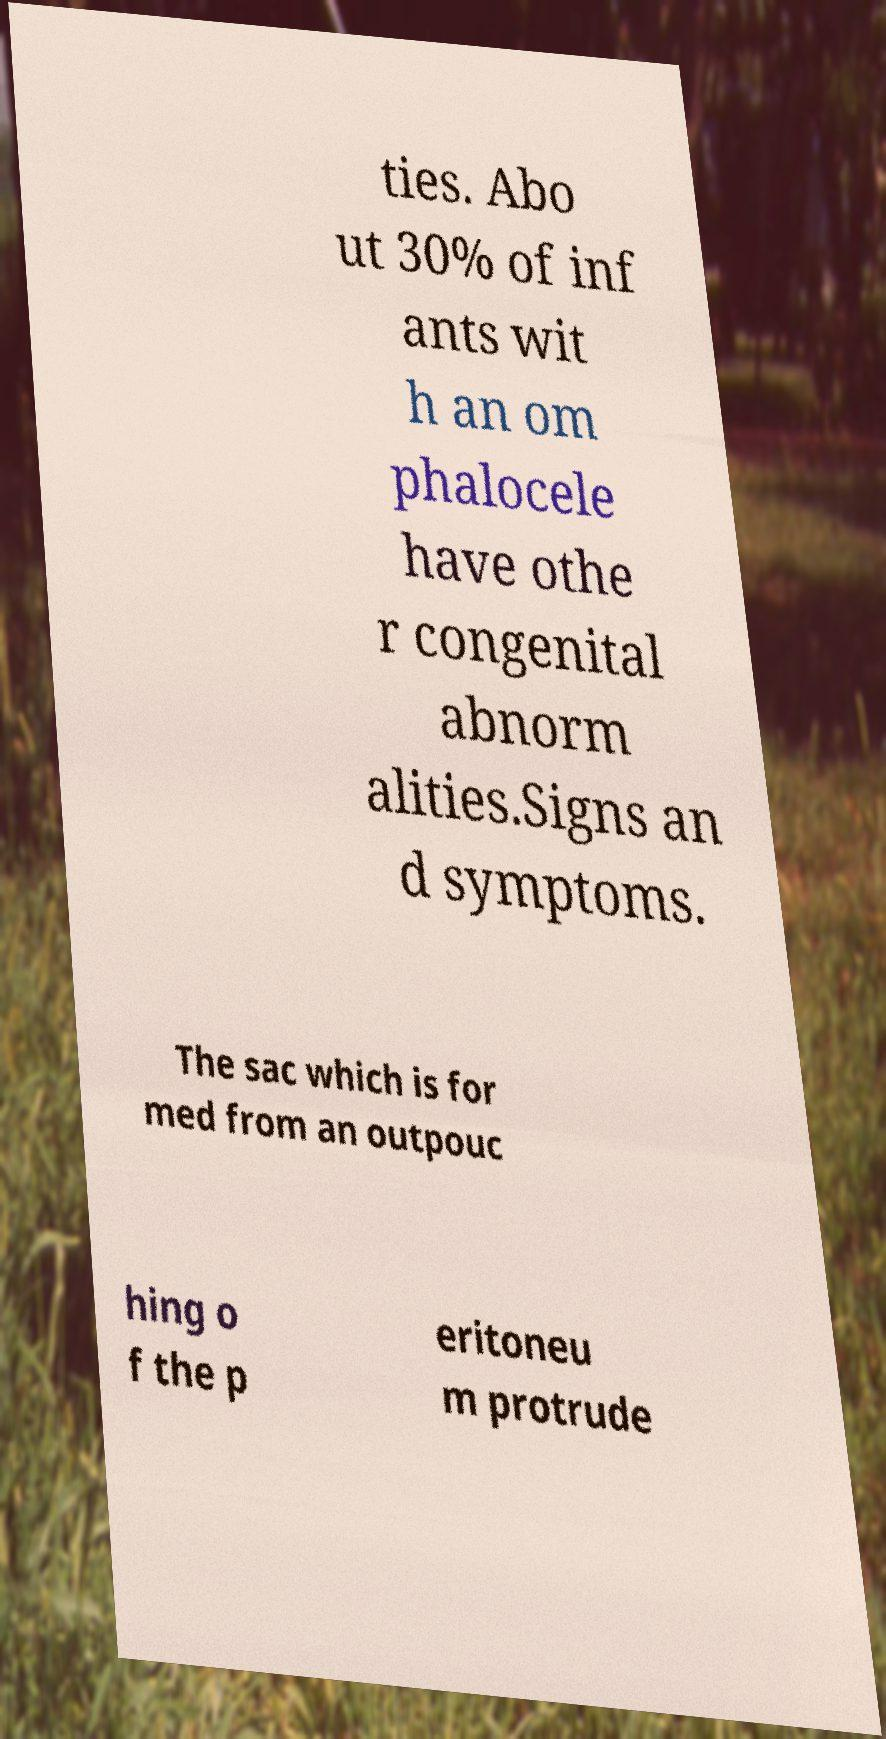There's text embedded in this image that I need extracted. Can you transcribe it verbatim? ties. Abo ut 30% of inf ants wit h an om phalocele have othe r congenital abnorm alities.Signs an d symptoms. The sac which is for med from an outpouc hing o f the p eritoneu m protrude 